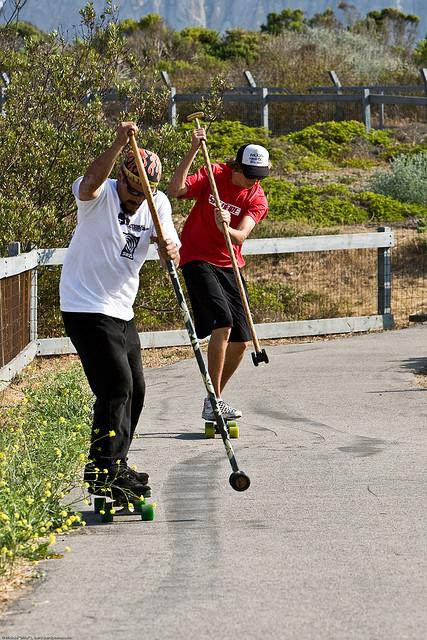What are the men riding on?

Choices:
A) roller blades
B) scooter
C) skateboard
D) bike skateboard 